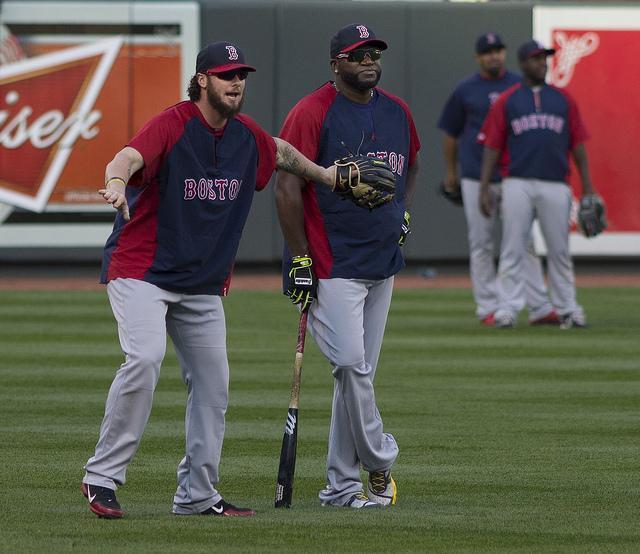How many teams are pictured in this photo?
Give a very brief answer. 1. How many boys in the team?
Give a very brief answer. 4. How many baseball bats are in the picture?
Give a very brief answer. 1. How many people can you see?
Give a very brief answer. 4. How many horses are in the scene?
Give a very brief answer. 0. 